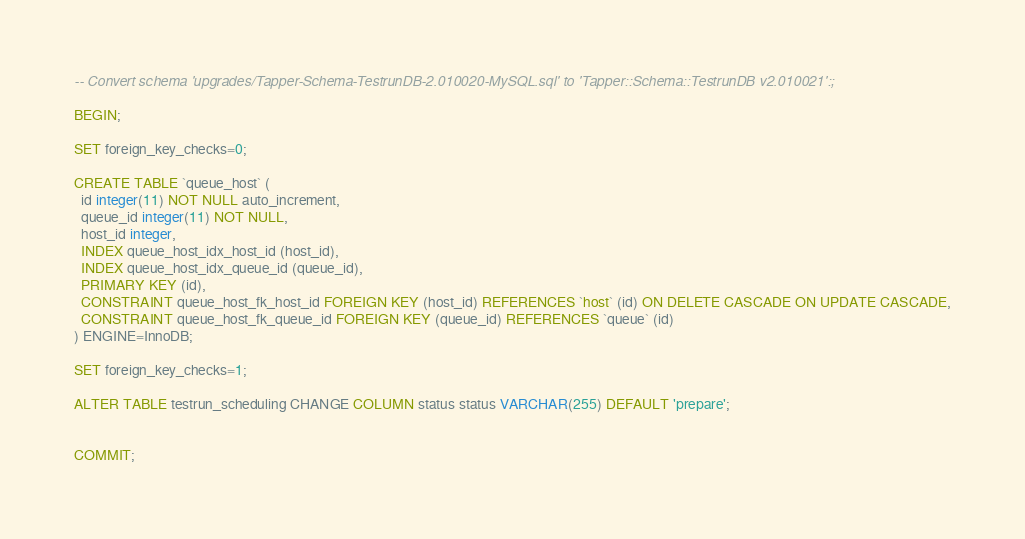Convert code to text. <code><loc_0><loc_0><loc_500><loc_500><_SQL_>-- Convert schema 'upgrades/Tapper-Schema-TestrunDB-2.010020-MySQL.sql' to 'Tapper::Schema::TestrunDB v2.010021':;

BEGIN;

SET foreign_key_checks=0;

CREATE TABLE `queue_host` (
  id integer(11) NOT NULL auto_increment,
  queue_id integer(11) NOT NULL,
  host_id integer,
  INDEX queue_host_idx_host_id (host_id),
  INDEX queue_host_idx_queue_id (queue_id),
  PRIMARY KEY (id),
  CONSTRAINT queue_host_fk_host_id FOREIGN KEY (host_id) REFERENCES `host` (id) ON DELETE CASCADE ON UPDATE CASCADE,
  CONSTRAINT queue_host_fk_queue_id FOREIGN KEY (queue_id) REFERENCES `queue` (id)
) ENGINE=InnoDB;

SET foreign_key_checks=1;

ALTER TABLE testrun_scheduling CHANGE COLUMN status status VARCHAR(255) DEFAULT 'prepare';


COMMIT;

</code> 